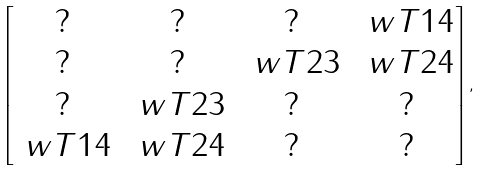<formula> <loc_0><loc_0><loc_500><loc_500>\begin{bmatrix} ? & ? & ? & \ w T { 1 4 } \\ ? & ? & \ w T { 2 3 } & \ w T { 2 4 } \\ ? & \ w T { 2 3 } & ? & ? \\ \ w T { 1 4 } & \ w T { 2 4 } & ? & ? \\ \end{bmatrix} ,</formula> 